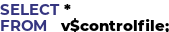Convert code to text. <code><loc_0><loc_0><loc_500><loc_500><_SQL_>SELECT *
FROM   v$controlfile;
</code> 